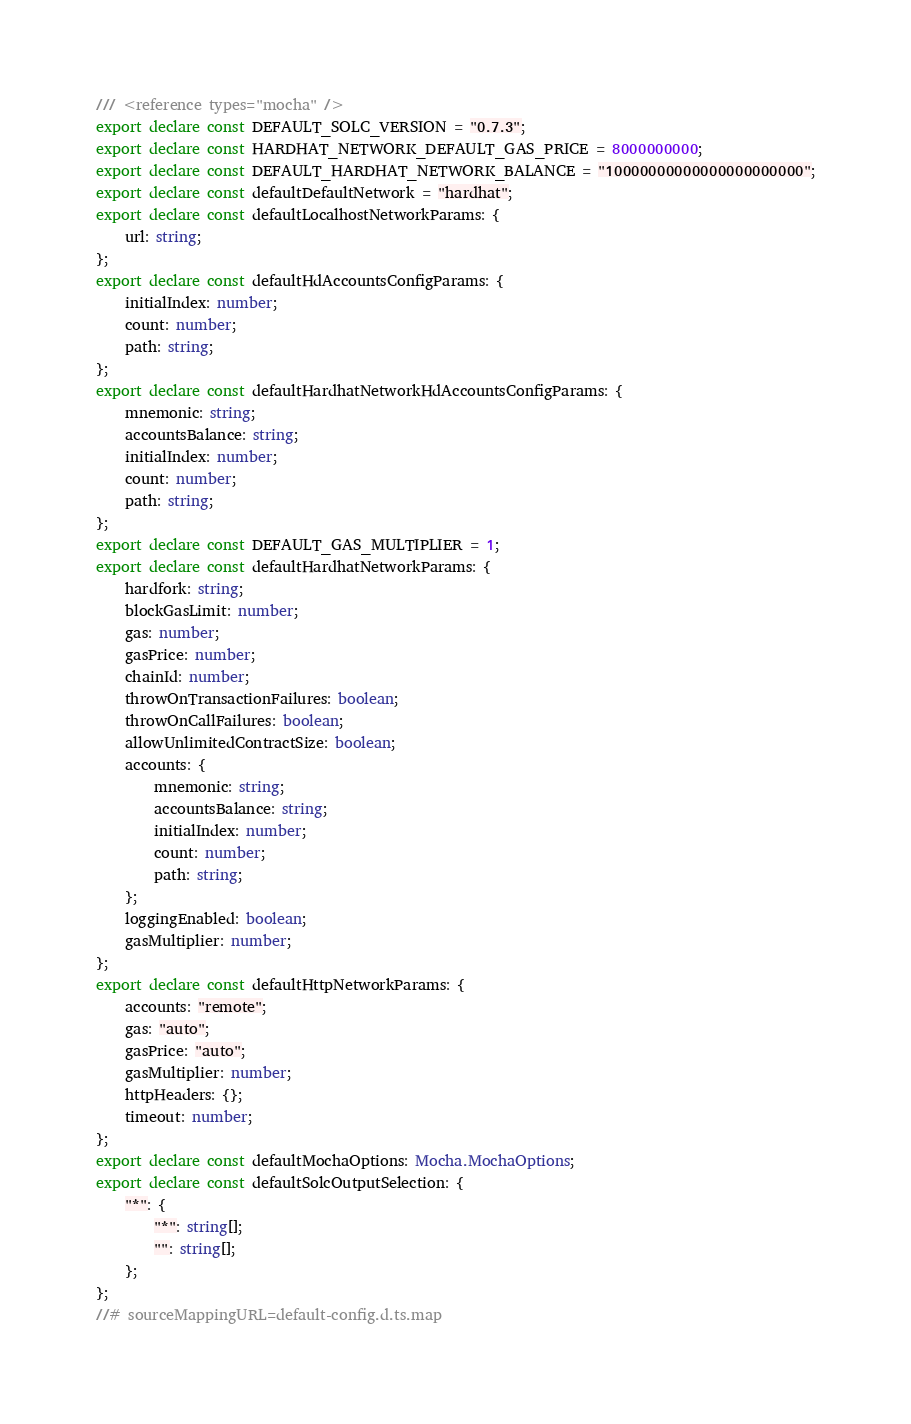Convert code to text. <code><loc_0><loc_0><loc_500><loc_500><_TypeScript_>/// <reference types="mocha" />
export declare const DEFAULT_SOLC_VERSION = "0.7.3";
export declare const HARDHAT_NETWORK_DEFAULT_GAS_PRICE = 8000000000;
export declare const DEFAULT_HARDHAT_NETWORK_BALANCE = "10000000000000000000000";
export declare const defaultDefaultNetwork = "hardhat";
export declare const defaultLocalhostNetworkParams: {
    url: string;
};
export declare const defaultHdAccountsConfigParams: {
    initialIndex: number;
    count: number;
    path: string;
};
export declare const defaultHardhatNetworkHdAccountsConfigParams: {
    mnemonic: string;
    accountsBalance: string;
    initialIndex: number;
    count: number;
    path: string;
};
export declare const DEFAULT_GAS_MULTIPLIER = 1;
export declare const defaultHardhatNetworkParams: {
    hardfork: string;
    blockGasLimit: number;
    gas: number;
    gasPrice: number;
    chainId: number;
    throwOnTransactionFailures: boolean;
    throwOnCallFailures: boolean;
    allowUnlimitedContractSize: boolean;
    accounts: {
        mnemonic: string;
        accountsBalance: string;
        initialIndex: number;
        count: number;
        path: string;
    };
    loggingEnabled: boolean;
    gasMultiplier: number;
};
export declare const defaultHttpNetworkParams: {
    accounts: "remote";
    gas: "auto";
    gasPrice: "auto";
    gasMultiplier: number;
    httpHeaders: {};
    timeout: number;
};
export declare const defaultMochaOptions: Mocha.MochaOptions;
export declare const defaultSolcOutputSelection: {
    "*": {
        "*": string[];
        "": string[];
    };
};
//# sourceMappingURL=default-config.d.ts.map</code> 